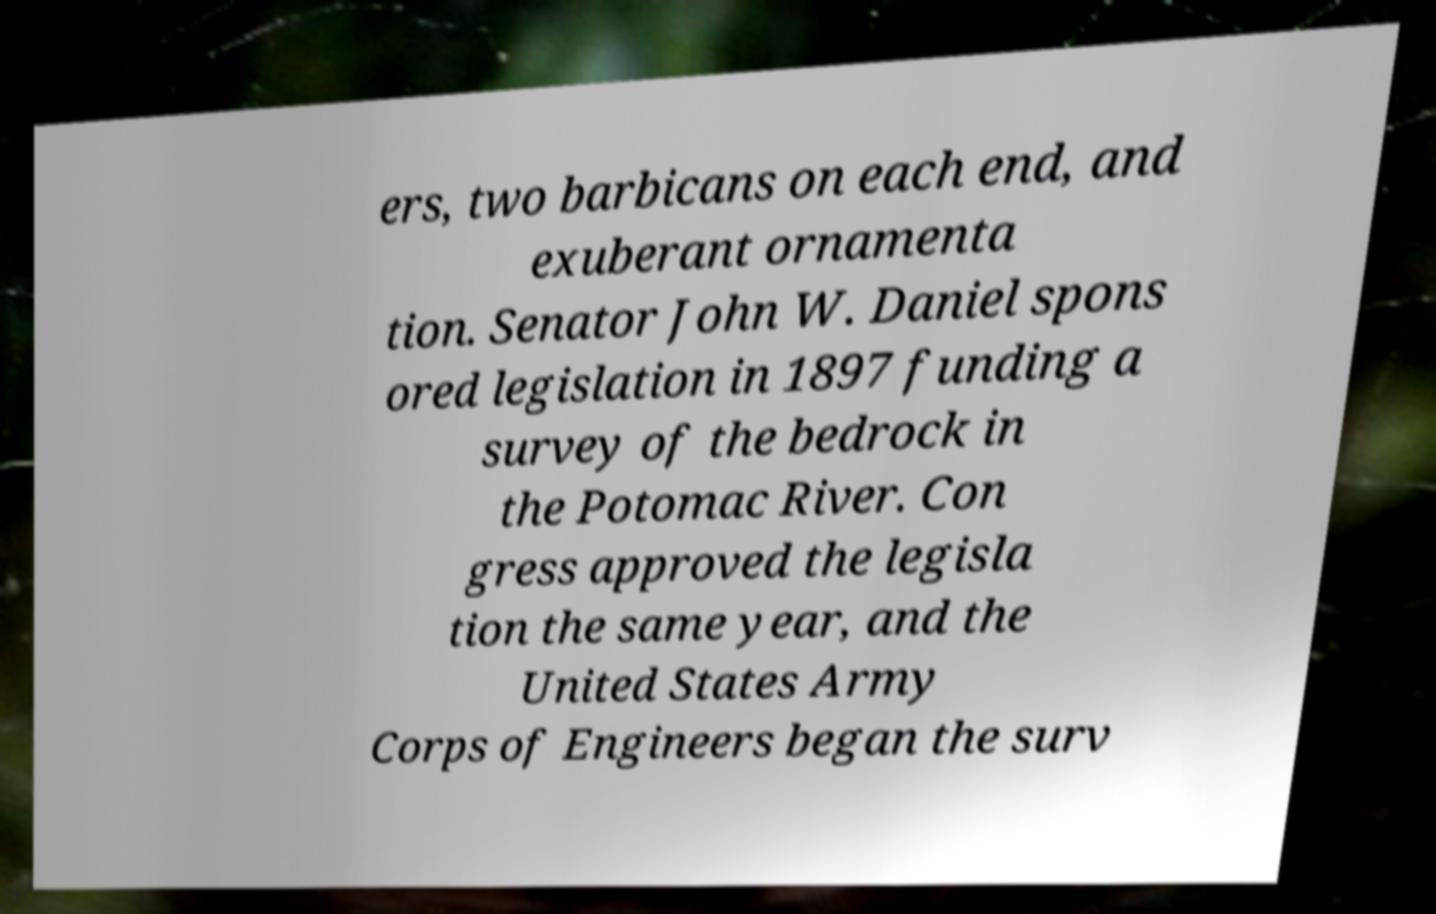Please identify and transcribe the text found in this image. ers, two barbicans on each end, and exuberant ornamenta tion. Senator John W. Daniel spons ored legislation in 1897 funding a survey of the bedrock in the Potomac River. Con gress approved the legisla tion the same year, and the United States Army Corps of Engineers began the surv 